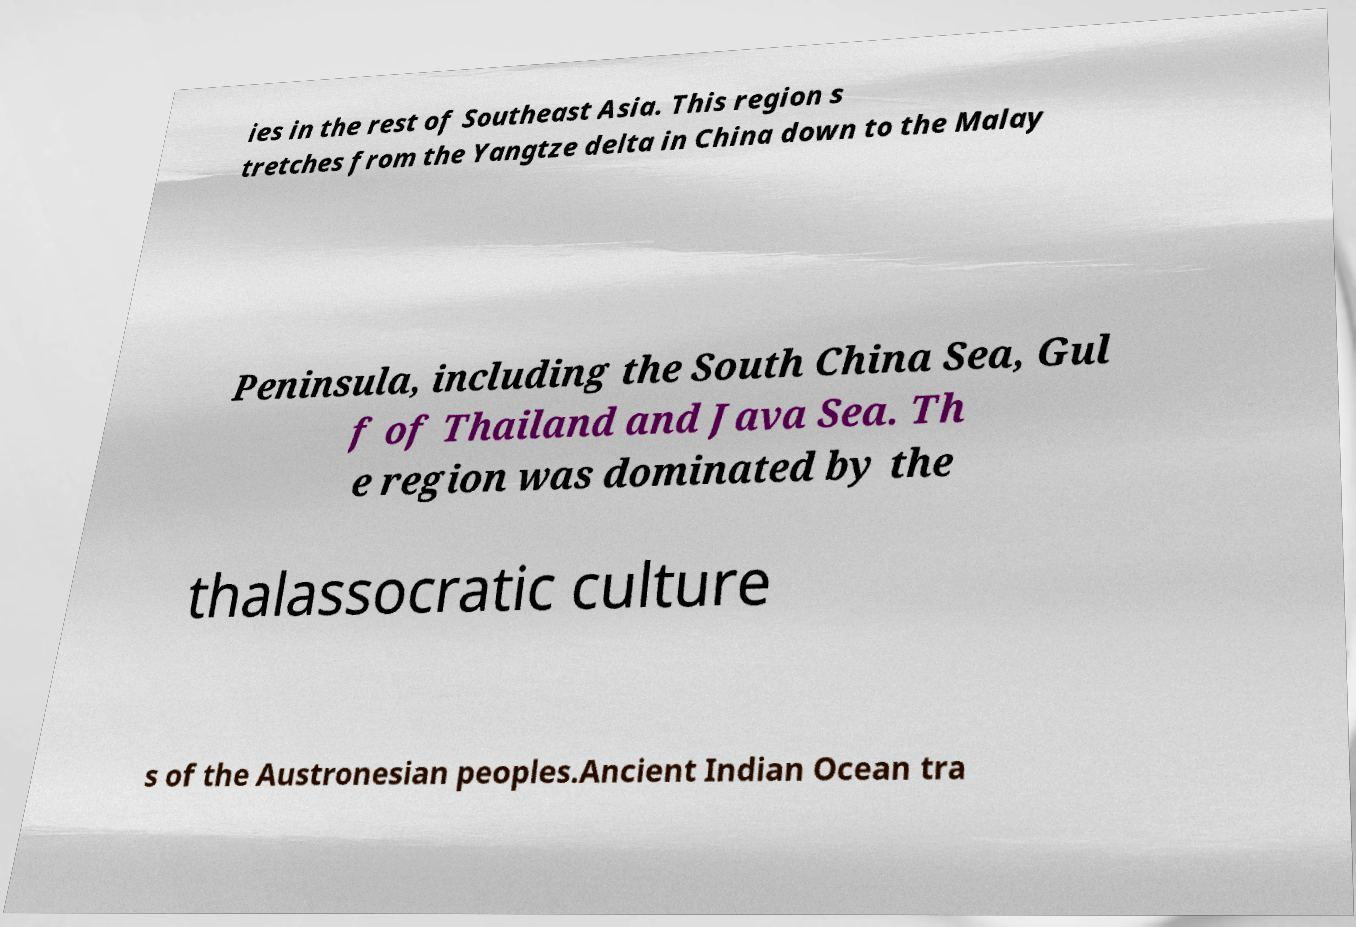For documentation purposes, I need the text within this image transcribed. Could you provide that? ies in the rest of Southeast Asia. This region s tretches from the Yangtze delta in China down to the Malay Peninsula, including the South China Sea, Gul f of Thailand and Java Sea. Th e region was dominated by the thalassocratic culture s of the Austronesian peoples.Ancient Indian Ocean tra 